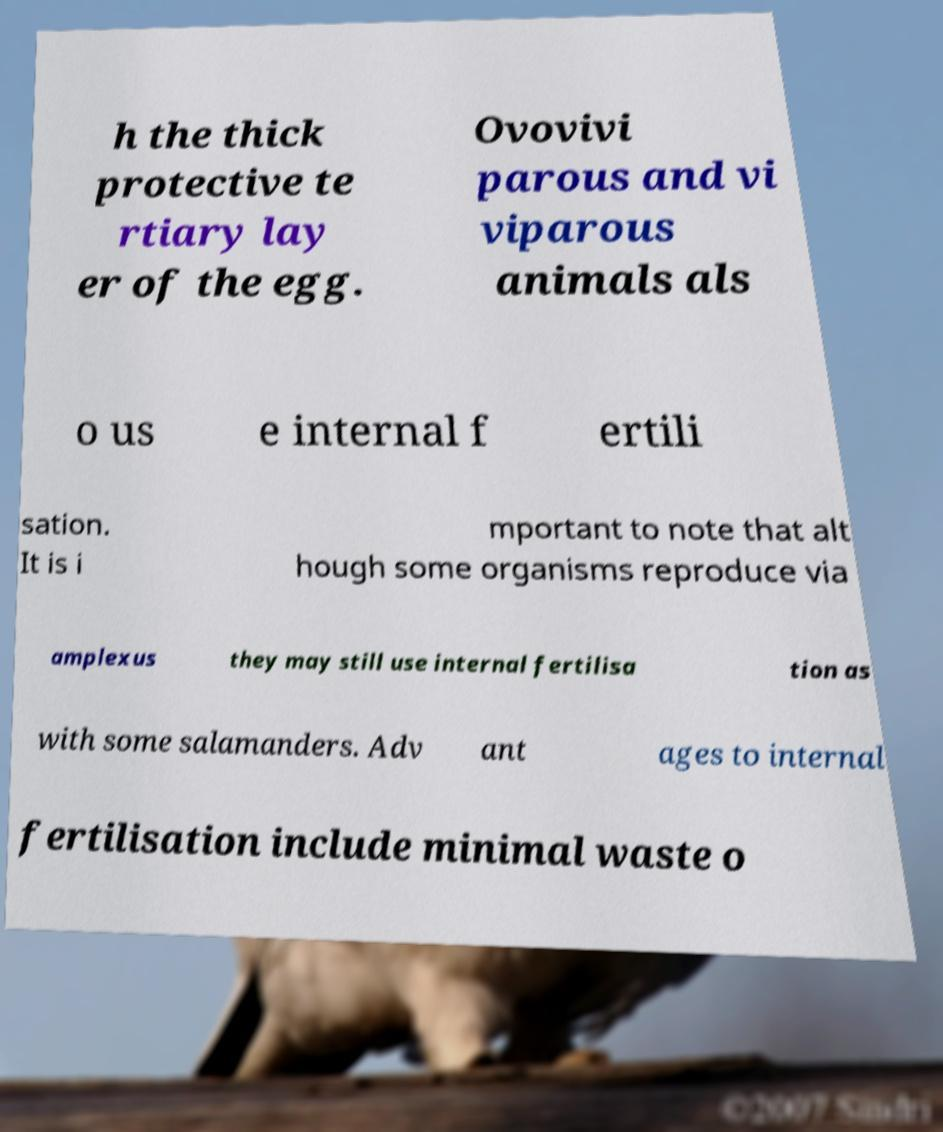Can you accurately transcribe the text from the provided image for me? h the thick protective te rtiary lay er of the egg. Ovovivi parous and vi viparous animals als o us e internal f ertili sation. It is i mportant to note that alt hough some organisms reproduce via amplexus they may still use internal fertilisa tion as with some salamanders. Adv ant ages to internal fertilisation include minimal waste o 